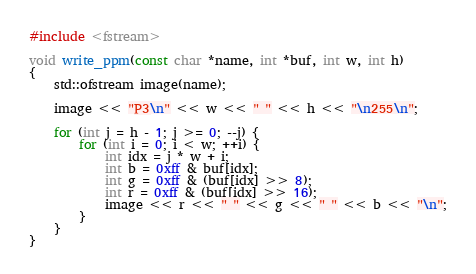Convert code to text. <code><loc_0><loc_0><loc_500><loc_500><_Cuda_>
#include <fstream>

void write_ppm(const char *name, int *buf, int w, int h)
{
	std::ofstream image(name);

	image << "P3\n" << w << " " << h << "\n255\n";

	for (int j = h - 1; j >= 0; --j) {
		for (int i = 0; i < w; ++i) {
			int idx = j * w + i;
			int b = 0xff & buf[idx];
			int g = 0xff & (buf[idx] >> 8);
			int r = 0xff & (buf[idx] >> 16);
			image << r << " " << g << " " << b << "\n";
		}
	}
}
</code> 